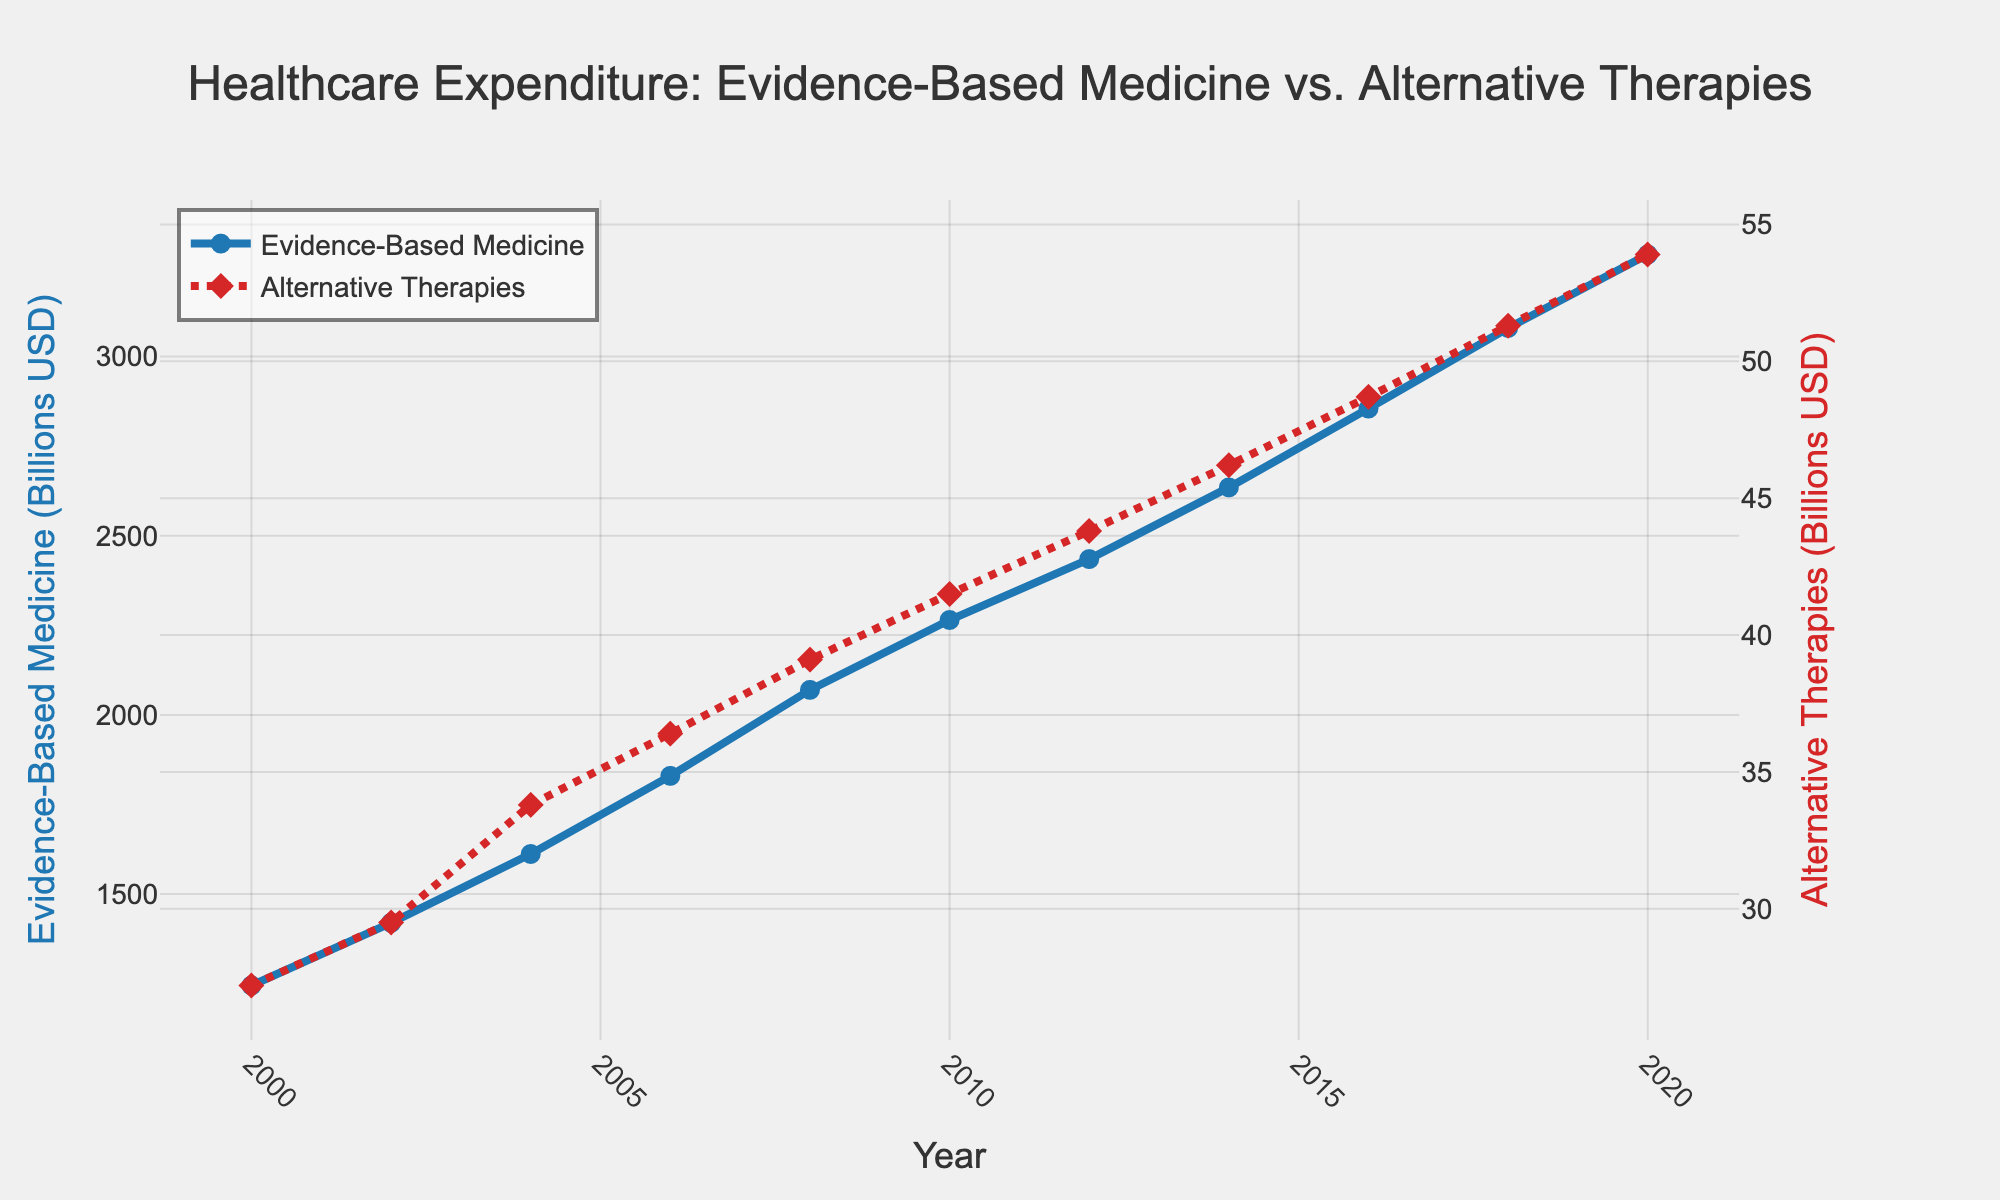What's the trend of healthcare expenditure on evidence-based medicine over the years? Observing the trend from the year 2000 to 2020, the expenditure on evidence-based medicine has shown a consistently increasing pattern.
Answer: Increasing How do the expenditures on alternative therapies compare to evidence-based medicine in 2020? In 2020, the expenditure on evidence-based medicine was about 3285 billion USD while the expenditure on alternative therapies was approximately 53.9 billion USD. This shows that expenditure on evidence-based medicine was significantly higher.
Answer: Evidenced-based medicine expenditure is much higher What's the average annual increase in expenditure on evidence-based medicine from 2000 to 2020? To find the average annual increase, we take the expenditure difference between 2020 and 2000 (3285 - 1245 = 2040) and divide by the number of years (2020 - 2000 = 20). The calculation is 2040/20 = 102 billion USD per year.
Answer: 102 billion USD per year What is the percent increase in expenditure for alternative therapies from 2000 to 2020? The percent increase is calculated by taking the difference in expenditure from 2020 and 2000 (53.9 - 27.2 = 26.7) and dividing by the 2000 expenditure (27.2), then multiplying by 100. This is (26.7 / 27.2) * 100 ≈ 98.16%.
Answer: Approximately 98.16% In which year did the expenditure on evidence-based medicine reach approximately twice that of alternative therapies? Looking at the data, around the year 2004, the expenditure on evidence-based medicine was 1612 billion USD, which is nearly double that of alternative therapies' expenditure of 33.8 billion USD.
Answer: 2004 Which category of healthcare expenditure has the steeper gradient? From visual inspection, the line representing evidence-based medicine has a steeper gradient compared to alternative therapies, indicating a faster increase in expenditure over time.
Answer: Evidence-based medicine During which 4-year period did the expenditure on evidence-based medicine grow the most? Observing the annual figures, the period from 2004 to 2008 saw the greatest increase in expenditure on evidence-based medicine, rising from 1612 to 2070 billion USD. This is an increase of 458 billion USD.
Answer: 2004-2008 Does the expenditure on alternative therapies show any significant spikes or drops? The expenditure on alternative therapies shows a steady, gradual increase without any significant spikes or drops over the examined years.
Answer: No significant spikes or drops By how much did the expenditure on evidence-based medicine surpass alternative therapies in 2010? In 2010, the expenditure on evidence-based medicine was 2265 billion USD and for alternative therapies, it was 41.5 billion USD. The difference is 2265 - 41.5 = 2223.5 billion USD.
Answer: 2223.5 billion USD 